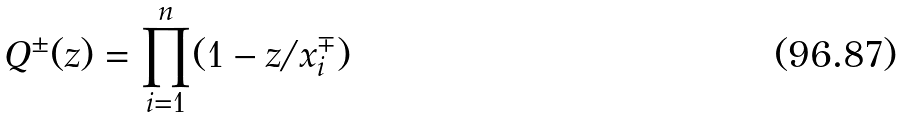Convert formula to latex. <formula><loc_0><loc_0><loc_500><loc_500>Q ^ { \pm } ( z ) = \prod _ { i = 1 } ^ { n } ( 1 - z / x _ { i } ^ { \mp } )</formula> 